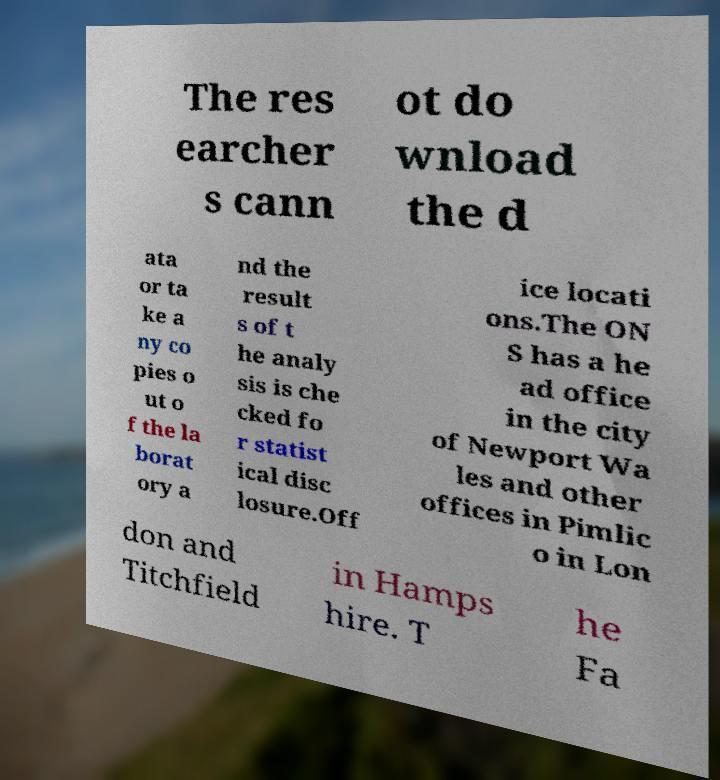I need the written content from this picture converted into text. Can you do that? The res earcher s cann ot do wnload the d ata or ta ke a ny co pies o ut o f the la borat ory a nd the result s of t he analy sis is che cked fo r statist ical disc losure.Off ice locati ons.The ON S has a he ad office in the city of Newport Wa les and other offices in Pimlic o in Lon don and Titchfield in Hamps hire. T he Fa 